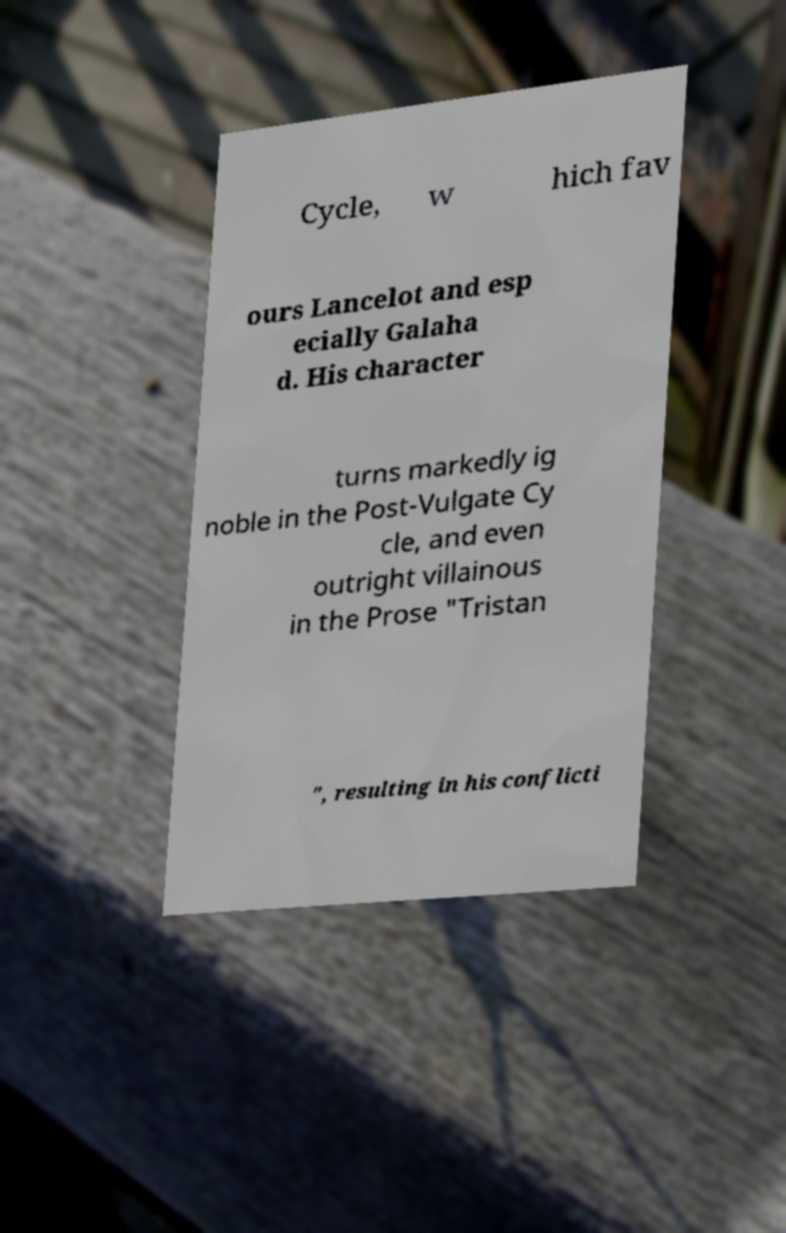What messages or text are displayed in this image? I need them in a readable, typed format. Cycle, w hich fav ours Lancelot and esp ecially Galaha d. His character turns markedly ig noble in the Post-Vulgate Cy cle, and even outright villainous in the Prose "Tristan ", resulting in his conflicti 